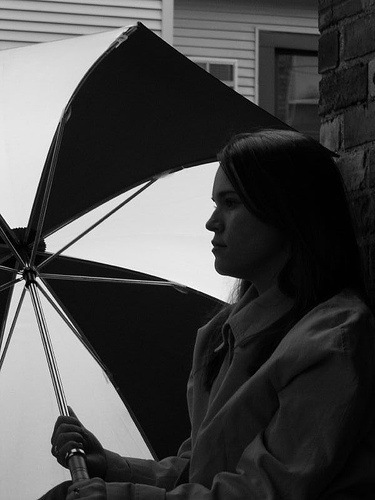Describe the objects in this image and their specific colors. I can see umbrella in darkgray, black, lightgray, and gray tones and people in darkgray, black, gray, and lightgray tones in this image. 